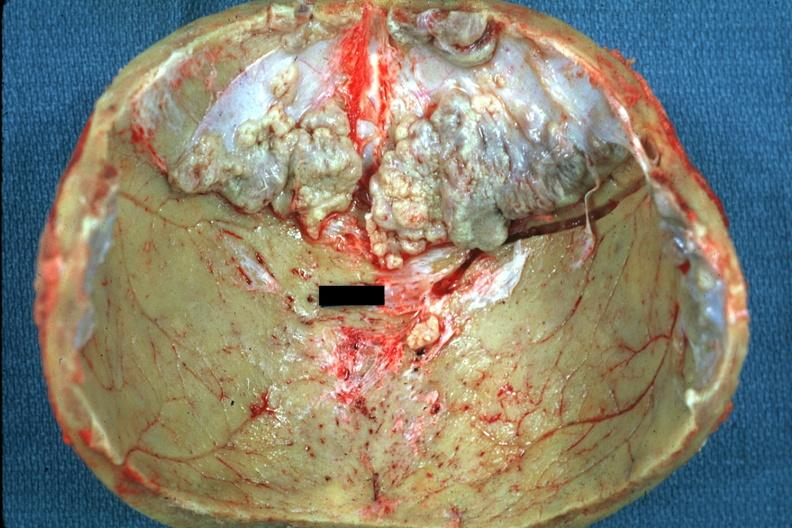s umbilical cord present?
Answer the question using a single word or phrase. No 